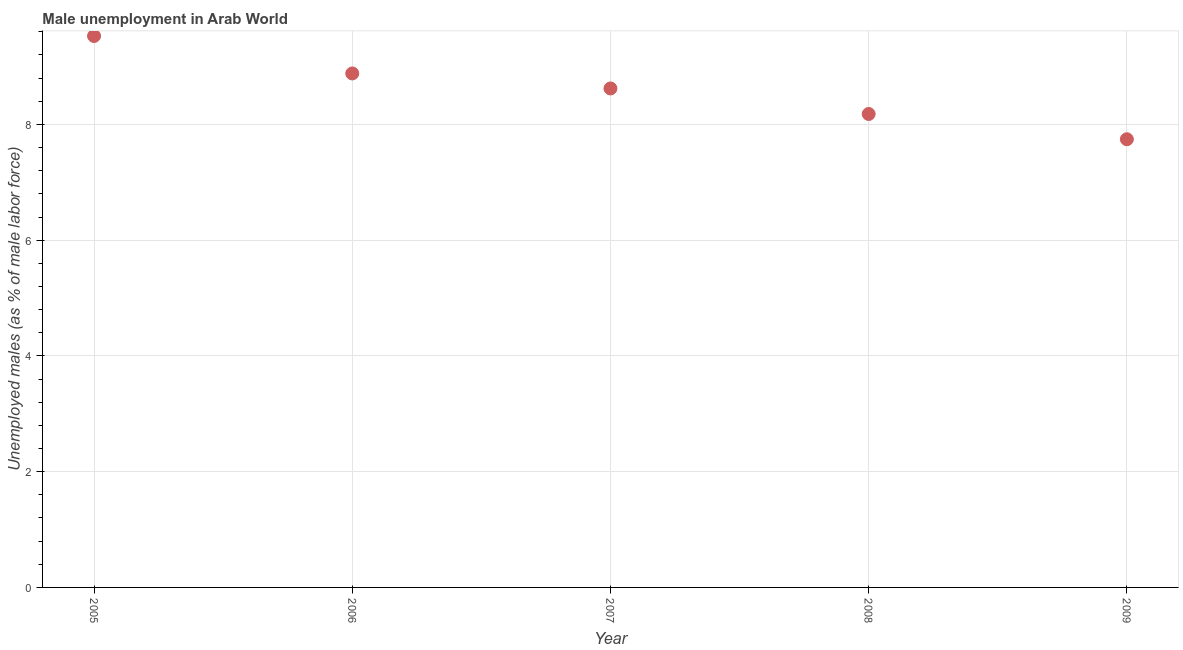What is the unemployed males population in 2005?
Ensure brevity in your answer.  9.53. Across all years, what is the maximum unemployed males population?
Provide a short and direct response. 9.53. Across all years, what is the minimum unemployed males population?
Keep it short and to the point. 7.74. In which year was the unemployed males population maximum?
Give a very brief answer. 2005. What is the sum of the unemployed males population?
Offer a very short reply. 42.95. What is the difference between the unemployed males population in 2007 and 2009?
Offer a very short reply. 0.88. What is the average unemployed males population per year?
Offer a terse response. 8.59. What is the median unemployed males population?
Your response must be concise. 8.62. Do a majority of the years between 2005 and 2008 (inclusive) have unemployed males population greater than 4.4 %?
Your response must be concise. Yes. What is the ratio of the unemployed males population in 2006 to that in 2009?
Give a very brief answer. 1.15. Is the unemployed males population in 2006 less than that in 2007?
Give a very brief answer. No. Is the difference between the unemployed males population in 2005 and 2009 greater than the difference between any two years?
Give a very brief answer. Yes. What is the difference between the highest and the second highest unemployed males population?
Your response must be concise. 0.65. Is the sum of the unemployed males population in 2005 and 2006 greater than the maximum unemployed males population across all years?
Your answer should be very brief. Yes. What is the difference between the highest and the lowest unemployed males population?
Keep it short and to the point. 1.78. In how many years, is the unemployed males population greater than the average unemployed males population taken over all years?
Provide a succinct answer. 3. How many dotlines are there?
Provide a succinct answer. 1. How many years are there in the graph?
Give a very brief answer. 5. What is the difference between two consecutive major ticks on the Y-axis?
Provide a succinct answer. 2. Are the values on the major ticks of Y-axis written in scientific E-notation?
Ensure brevity in your answer.  No. What is the title of the graph?
Your answer should be compact. Male unemployment in Arab World. What is the label or title of the X-axis?
Ensure brevity in your answer.  Year. What is the label or title of the Y-axis?
Provide a succinct answer. Unemployed males (as % of male labor force). What is the Unemployed males (as % of male labor force) in 2005?
Offer a very short reply. 9.53. What is the Unemployed males (as % of male labor force) in 2006?
Make the answer very short. 8.88. What is the Unemployed males (as % of male labor force) in 2007?
Your response must be concise. 8.62. What is the Unemployed males (as % of male labor force) in 2008?
Ensure brevity in your answer.  8.18. What is the Unemployed males (as % of male labor force) in 2009?
Your answer should be compact. 7.74. What is the difference between the Unemployed males (as % of male labor force) in 2005 and 2006?
Your answer should be very brief. 0.65. What is the difference between the Unemployed males (as % of male labor force) in 2005 and 2007?
Offer a terse response. 0.91. What is the difference between the Unemployed males (as % of male labor force) in 2005 and 2008?
Your answer should be very brief. 1.35. What is the difference between the Unemployed males (as % of male labor force) in 2005 and 2009?
Ensure brevity in your answer.  1.78. What is the difference between the Unemployed males (as % of male labor force) in 2006 and 2007?
Keep it short and to the point. 0.26. What is the difference between the Unemployed males (as % of male labor force) in 2006 and 2008?
Make the answer very short. 0.7. What is the difference between the Unemployed males (as % of male labor force) in 2006 and 2009?
Provide a short and direct response. 1.14. What is the difference between the Unemployed males (as % of male labor force) in 2007 and 2008?
Provide a succinct answer. 0.44. What is the difference between the Unemployed males (as % of male labor force) in 2007 and 2009?
Offer a very short reply. 0.88. What is the difference between the Unemployed males (as % of male labor force) in 2008 and 2009?
Give a very brief answer. 0.44. What is the ratio of the Unemployed males (as % of male labor force) in 2005 to that in 2006?
Offer a terse response. 1.07. What is the ratio of the Unemployed males (as % of male labor force) in 2005 to that in 2007?
Keep it short and to the point. 1.1. What is the ratio of the Unemployed males (as % of male labor force) in 2005 to that in 2008?
Offer a very short reply. 1.17. What is the ratio of the Unemployed males (as % of male labor force) in 2005 to that in 2009?
Ensure brevity in your answer.  1.23. What is the ratio of the Unemployed males (as % of male labor force) in 2006 to that in 2007?
Provide a succinct answer. 1.03. What is the ratio of the Unemployed males (as % of male labor force) in 2006 to that in 2008?
Make the answer very short. 1.09. What is the ratio of the Unemployed males (as % of male labor force) in 2006 to that in 2009?
Keep it short and to the point. 1.15. What is the ratio of the Unemployed males (as % of male labor force) in 2007 to that in 2008?
Your answer should be compact. 1.05. What is the ratio of the Unemployed males (as % of male labor force) in 2007 to that in 2009?
Give a very brief answer. 1.11. What is the ratio of the Unemployed males (as % of male labor force) in 2008 to that in 2009?
Your answer should be very brief. 1.06. 